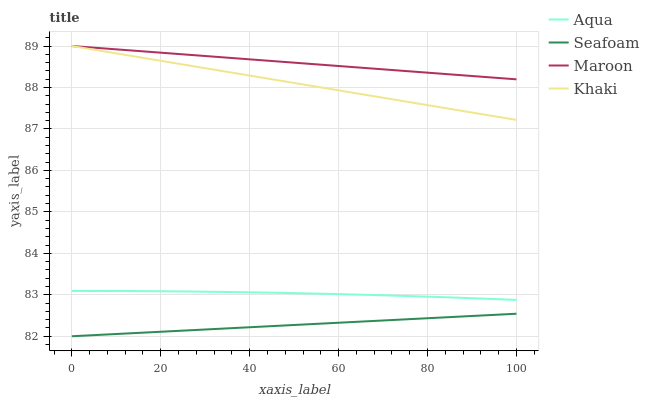Does Seafoam have the minimum area under the curve?
Answer yes or no. Yes. Does Maroon have the maximum area under the curve?
Answer yes or no. Yes. Does Aqua have the minimum area under the curve?
Answer yes or no. No. Does Aqua have the maximum area under the curve?
Answer yes or no. No. Is Maroon the smoothest?
Answer yes or no. Yes. Is Aqua the roughest?
Answer yes or no. Yes. Is Seafoam the smoothest?
Answer yes or no. No. Is Seafoam the roughest?
Answer yes or no. No. Does Seafoam have the lowest value?
Answer yes or no. Yes. Does Aqua have the lowest value?
Answer yes or no. No. Does Maroon have the highest value?
Answer yes or no. Yes. Does Aqua have the highest value?
Answer yes or no. No. Is Seafoam less than Aqua?
Answer yes or no. Yes. Is Maroon greater than Aqua?
Answer yes or no. Yes. Does Khaki intersect Maroon?
Answer yes or no. Yes. Is Khaki less than Maroon?
Answer yes or no. No. Is Khaki greater than Maroon?
Answer yes or no. No. Does Seafoam intersect Aqua?
Answer yes or no. No. 